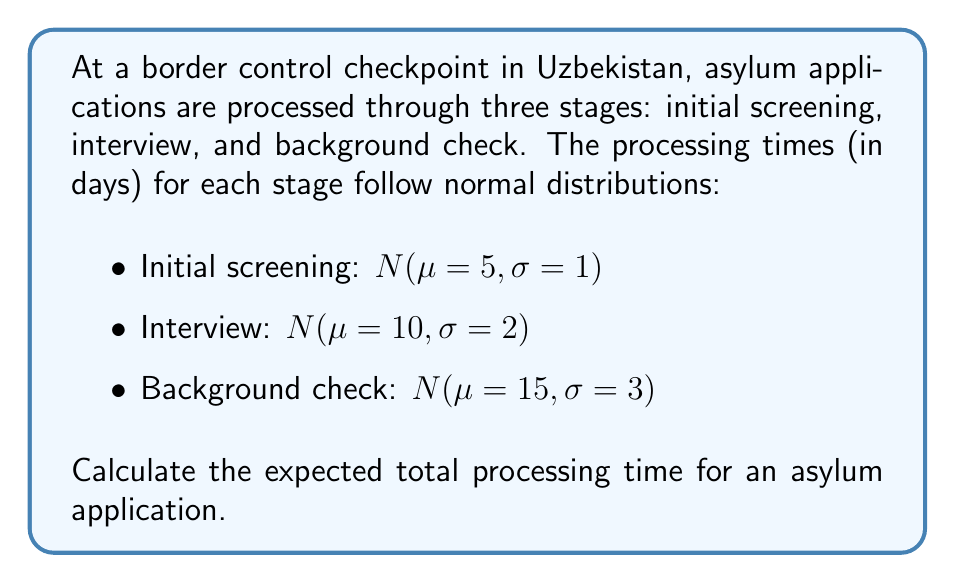Provide a solution to this math problem. To calculate the expected total processing time, we need to sum the expected values of each stage:

1) For a normal distribution, the expected value is equal to its mean ($\mu$).

2) Expected time for initial screening:
   $E(\text{Initial screening}) = 5$ days

3) Expected time for interview:
   $E(\text{Interview}) = 10$ days

4) Expected time for background check:
   $E(\text{Background check}) = 15$ days

5) The total expected processing time is the sum of these individual expected times:

   $$E(\text{Total}) = E(\text{Initial screening}) + E(\text{Interview}) + E(\text{Background check})$$
   $$E(\text{Total}) = 5 + 10 + 15 = 30\text{ days}$$

Therefore, the expected total processing time for an asylum application is 30 days.
Answer: 30 days 